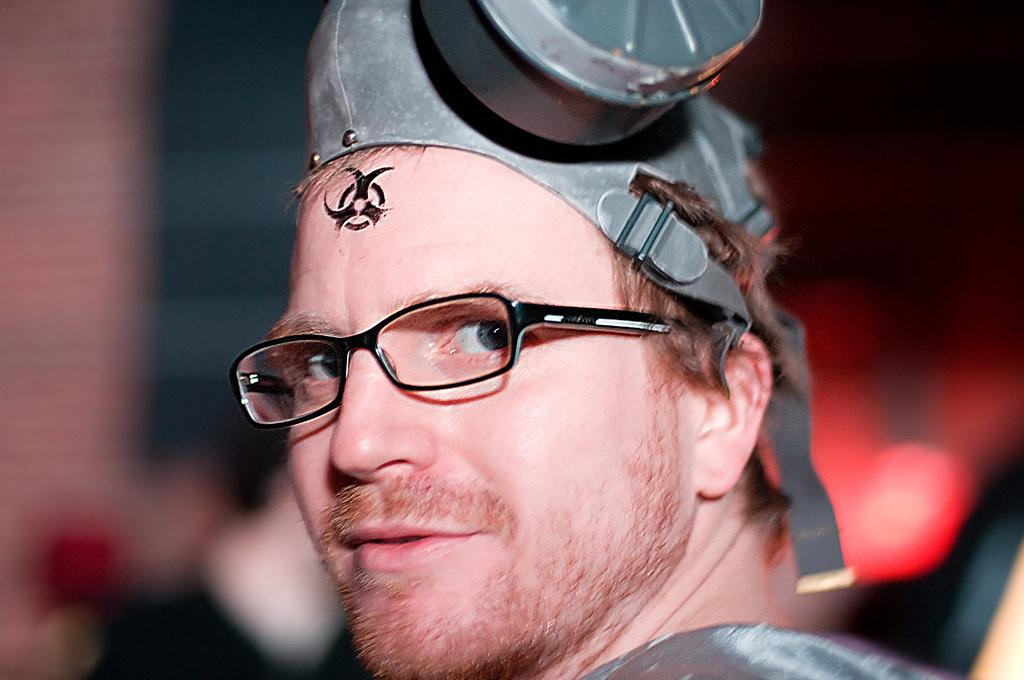Who is present in the image? There is a man in the image. What is the man wearing on his face? The man is wearing spectacles. What is the man wearing on his head? The man is wearing a hat around his head. How is the background of the man depicted in the image? The background of the man is blurred. What is the hour of the day depicted in the image? The provided facts do not mention the time of day, so it cannot be determined from the image. 